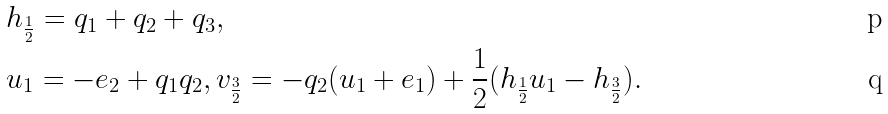<formula> <loc_0><loc_0><loc_500><loc_500>& h _ { \frac { 1 } { 2 } } = q _ { 1 } + q _ { 2 } + q _ { 3 } , \\ & u _ { 1 } = - e _ { 2 } + q _ { 1 } q _ { 2 } , v _ { \frac { 3 } { 2 } } = - q _ { 2 } ( u _ { 1 } + e _ { 1 } ) + \frac { 1 } { 2 } ( h _ { \frac { 1 } { 2 } } u _ { 1 } - h _ { \frac { 3 } { 2 } } ) .</formula> 